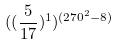<formula> <loc_0><loc_0><loc_500><loc_500>( ( \frac { 5 } { 1 7 } ) ^ { 1 } ) ^ { ( 2 7 0 ^ { 2 } - 8 ) }</formula> 